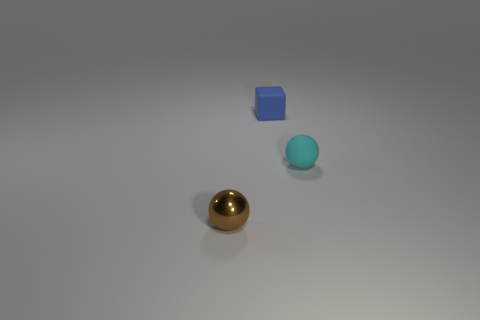Is the shape of the metal object the same as the rubber thing in front of the blue rubber cube?
Provide a short and direct response. Yes. Are there any small cyan spheres made of the same material as the small blue block?
Make the answer very short. Yes. There is a tiny sphere in front of the small sphere that is behind the tiny metal sphere; what is it made of?
Offer a terse response. Metal. What shape is the small matte thing that is in front of the blue block?
Your answer should be very brief. Sphere. There is a rubber object that is behind the sphere that is behind the tiny brown ball; how many brown things are behind it?
Keep it short and to the point. 0. Are there the same number of cyan spheres that are on the left side of the small blue block and small matte objects?
Ensure brevity in your answer.  No. How many blocks are brown shiny objects or rubber objects?
Provide a succinct answer. 1. Is the color of the metallic ball the same as the small cube?
Offer a very short reply. No. Are there an equal number of blue rubber cubes that are in front of the small cyan thing and blue matte cubes to the right of the small brown shiny thing?
Your answer should be very brief. No. What is the color of the rubber cube?
Make the answer very short. Blue. 